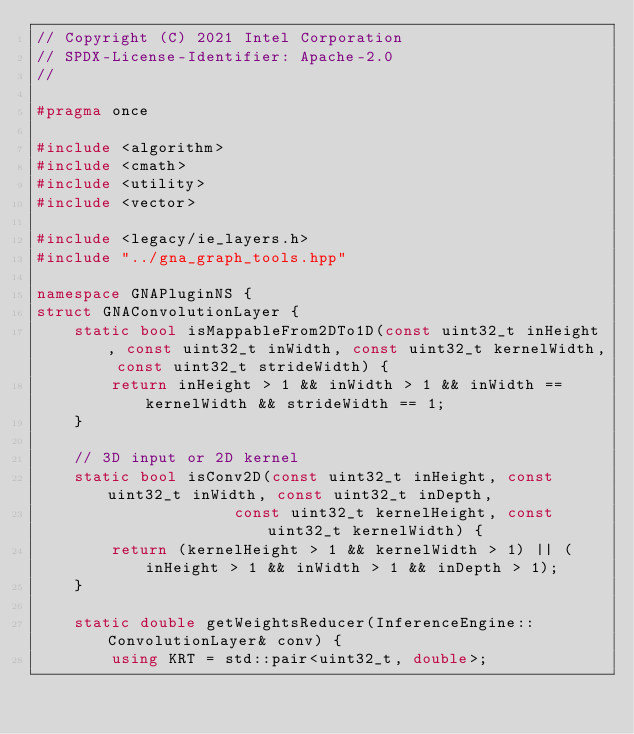Convert code to text. <code><loc_0><loc_0><loc_500><loc_500><_C++_>// Copyright (C) 2021 Intel Corporation
// SPDX-License-Identifier: Apache-2.0
//

#pragma once

#include <algorithm>
#include <cmath>
#include <utility>
#include <vector>

#include <legacy/ie_layers.h>
#include "../gna_graph_tools.hpp"

namespace GNAPluginNS {
struct GNAConvolutionLayer {
    static bool isMappableFrom2DTo1D(const uint32_t inHeight, const uint32_t inWidth, const uint32_t kernelWidth, const uint32_t strideWidth) {
        return inHeight > 1 && inWidth > 1 && inWidth == kernelWidth && strideWidth == 1;
    }

    // 3D input or 2D kernel
    static bool isConv2D(const uint32_t inHeight, const uint32_t inWidth, const uint32_t inDepth,
                     const uint32_t kernelHeight, const uint32_t kernelWidth) {
        return (kernelHeight > 1 && kernelWidth > 1) || (inHeight > 1 && inWidth > 1 && inDepth > 1);
    }

    static double getWeightsReducer(InferenceEngine::ConvolutionLayer& conv) {
        using KRT = std::pair<uint32_t, double>;</code> 